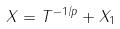<formula> <loc_0><loc_0><loc_500><loc_500>X = T ^ { - 1 / p } + X _ { 1 }</formula> 